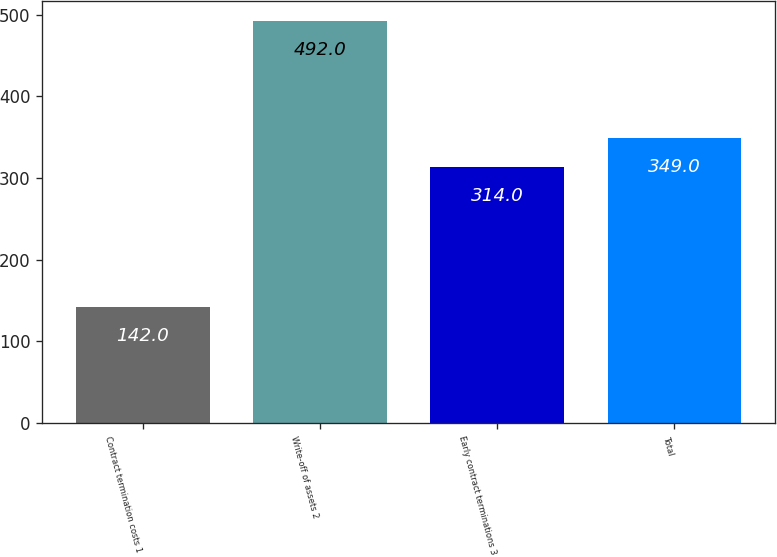Convert chart. <chart><loc_0><loc_0><loc_500><loc_500><bar_chart><fcel>Contract termination costs 1<fcel>Write-off of assets 2<fcel>Early contract terminations 3<fcel>Total<nl><fcel>142<fcel>492<fcel>314<fcel>349<nl></chart> 